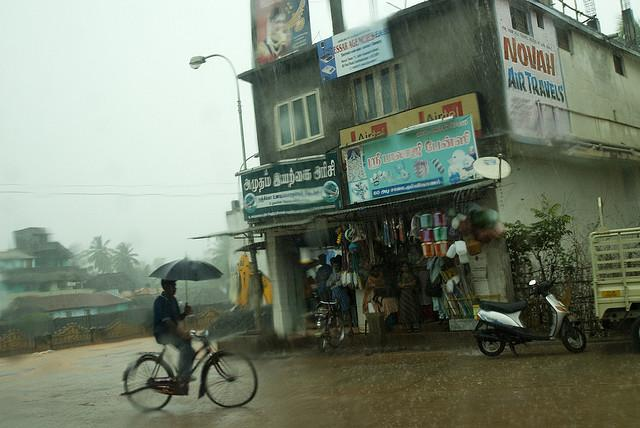Which person gets the most soaked?

Choices:
A) woman
B) cyclist
C) short man
D) tall man cyclist 